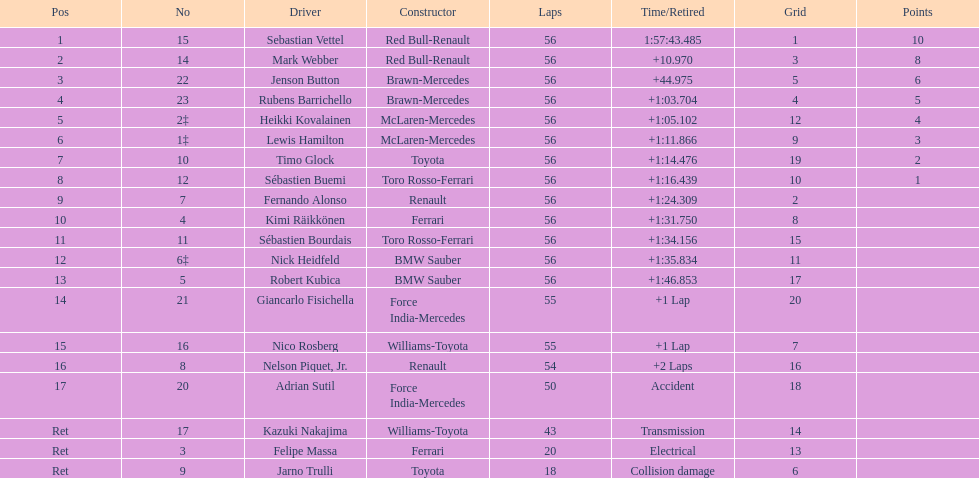Which constructor did heikki kovalainen and lewis hamilton both have? McLaren-Mercedes. 